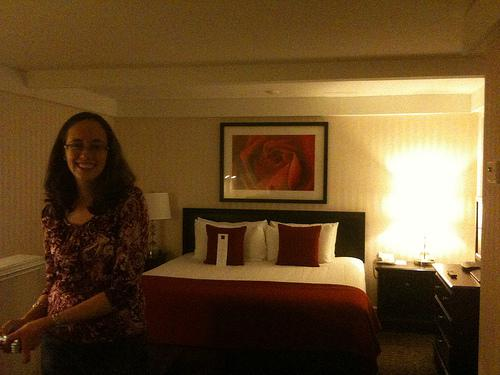Question: what color is the picture of on the wall?
Choices:
A. Purple.
B. Rose.
C. Orange.
D. Red.
Answer with the letter. Answer: B Question: what is she wearing on her face?
Choices:
A. Make-up.
B. Face paint.
C. Glasses.
D. Temporary tattoos.
Answer with the letter. Answer: C 